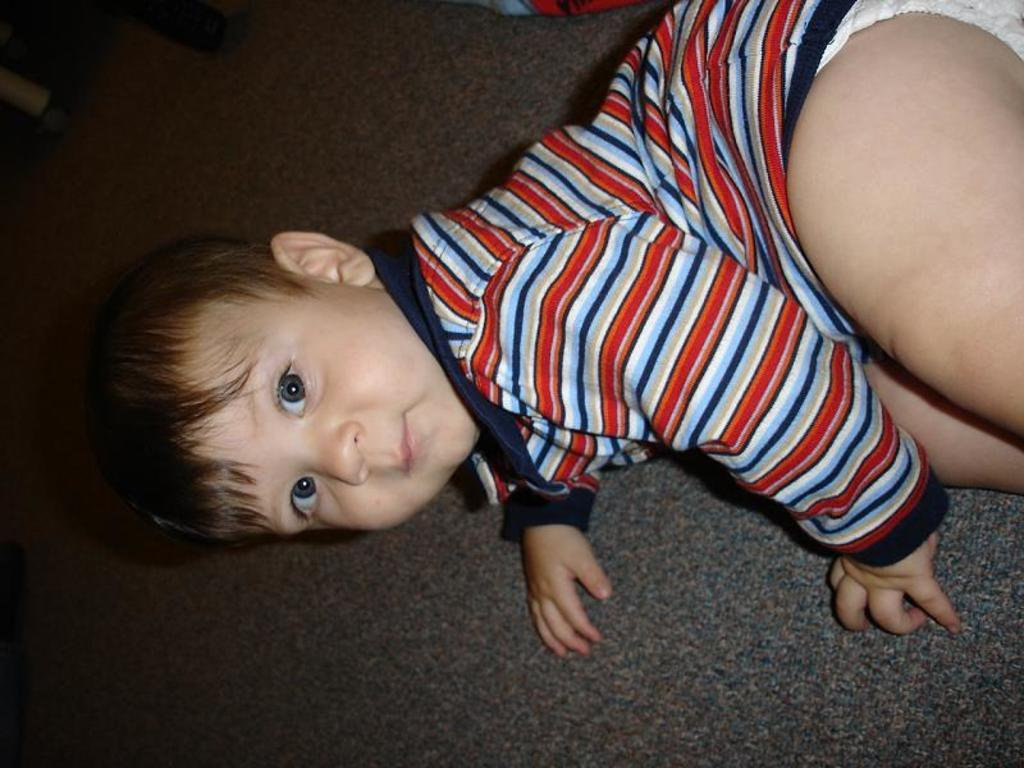What is the main subject of the image? There is a baby in the image. Where is the baby located in the image? The baby is on the floor. What type of sidewalk is visible in the image? There is no sidewalk present in the image; it only features a baby on the floor. How many clocks can be seen in the image? There are no clocks visible in the image, as it only features a baby on the floor. 